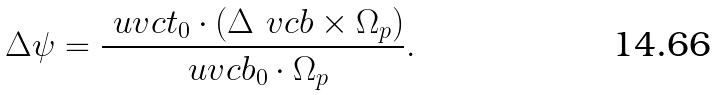<formula> <loc_0><loc_0><loc_500><loc_500>\Delta \psi = \frac { \ u v c { t } _ { 0 } \cdot ( \Delta \ v c { b } \times \Omega _ { p } ) } { \ u v c { b } _ { 0 } \cdot \Omega _ { p } } .</formula> 